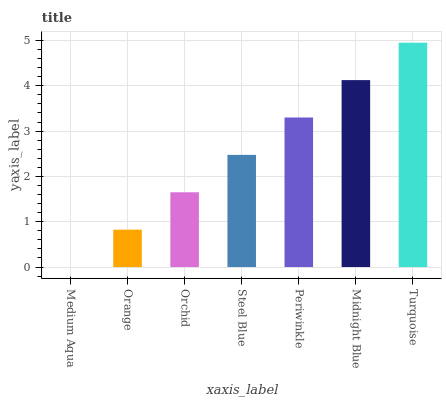Is Medium Aqua the minimum?
Answer yes or no. Yes. Is Turquoise the maximum?
Answer yes or no. Yes. Is Orange the minimum?
Answer yes or no. No. Is Orange the maximum?
Answer yes or no. No. Is Orange greater than Medium Aqua?
Answer yes or no. Yes. Is Medium Aqua less than Orange?
Answer yes or no. Yes. Is Medium Aqua greater than Orange?
Answer yes or no. No. Is Orange less than Medium Aqua?
Answer yes or no. No. Is Steel Blue the high median?
Answer yes or no. Yes. Is Steel Blue the low median?
Answer yes or no. Yes. Is Midnight Blue the high median?
Answer yes or no. No. Is Turquoise the low median?
Answer yes or no. No. 